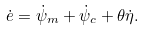<formula> <loc_0><loc_0><loc_500><loc_500>\dot { e } = \dot { \psi } _ { m } + \dot { \psi } _ { c } + \theta \dot { \eta } .</formula> 